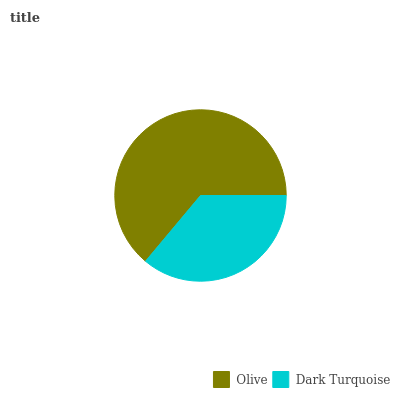Is Dark Turquoise the minimum?
Answer yes or no. Yes. Is Olive the maximum?
Answer yes or no. Yes. Is Dark Turquoise the maximum?
Answer yes or no. No. Is Olive greater than Dark Turquoise?
Answer yes or no. Yes. Is Dark Turquoise less than Olive?
Answer yes or no. Yes. Is Dark Turquoise greater than Olive?
Answer yes or no. No. Is Olive less than Dark Turquoise?
Answer yes or no. No. Is Olive the high median?
Answer yes or no. Yes. Is Dark Turquoise the low median?
Answer yes or no. Yes. Is Dark Turquoise the high median?
Answer yes or no. No. Is Olive the low median?
Answer yes or no. No. 